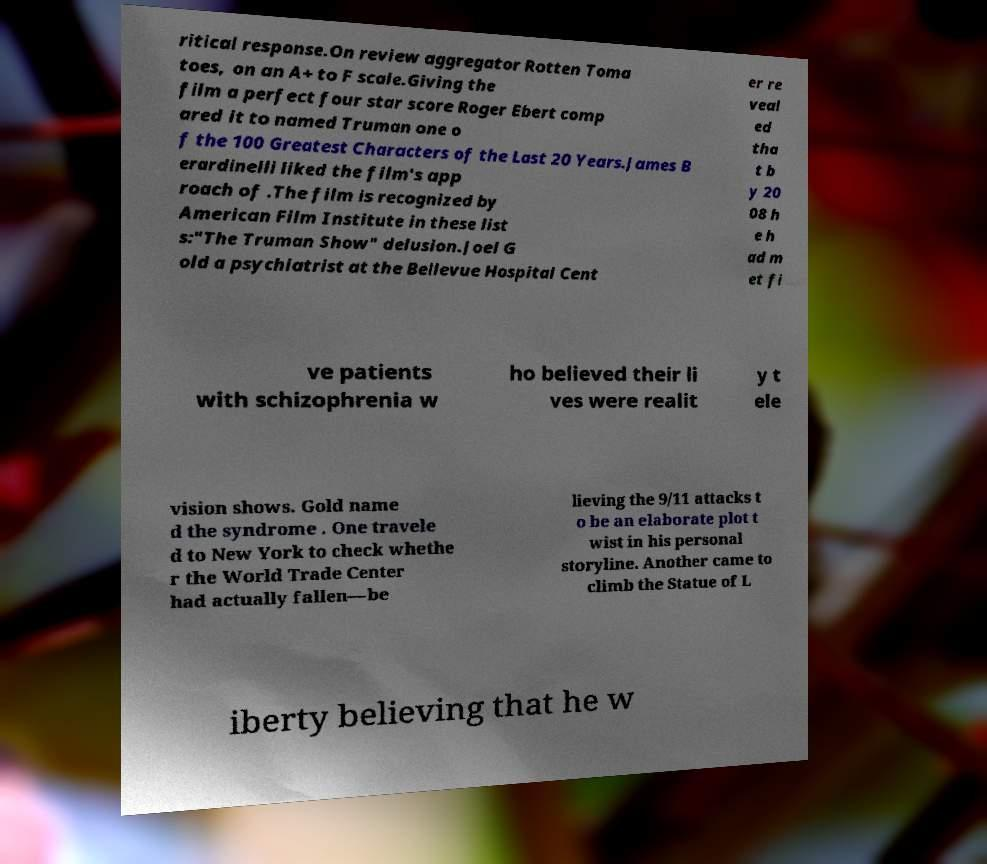What messages or text are displayed in this image? I need them in a readable, typed format. ritical response.On review aggregator Rotten Toma toes, on an A+ to F scale.Giving the film a perfect four star score Roger Ebert comp ared it to named Truman one o f the 100 Greatest Characters of the Last 20 Years.James B erardinelli liked the film's app roach of .The film is recognized by American Film Institute in these list s:"The Truman Show" delusion.Joel G old a psychiatrist at the Bellevue Hospital Cent er re veal ed tha t b y 20 08 h e h ad m et fi ve patients with schizophrenia w ho believed their li ves were realit y t ele vision shows. Gold name d the syndrome . One travele d to New York to check whethe r the World Trade Center had actually fallen—be lieving the 9/11 attacks t o be an elaborate plot t wist in his personal storyline. Another came to climb the Statue of L iberty believing that he w 